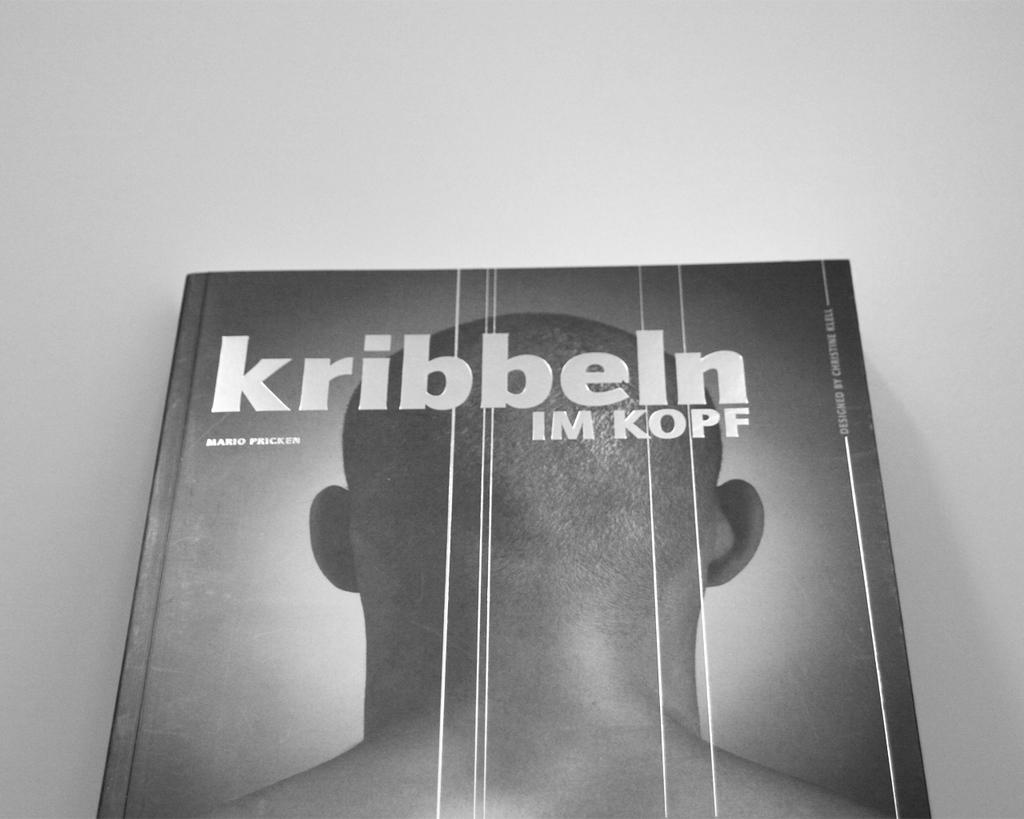<image>
Render a clear and concise summary of the photo. book titled kribbeln im kopf that has photo of back of a mans shaved head 